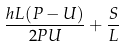<formula> <loc_0><loc_0><loc_500><loc_500>\frac { h L ( P - U ) } { 2 P U } + \frac { S } { L }</formula> 